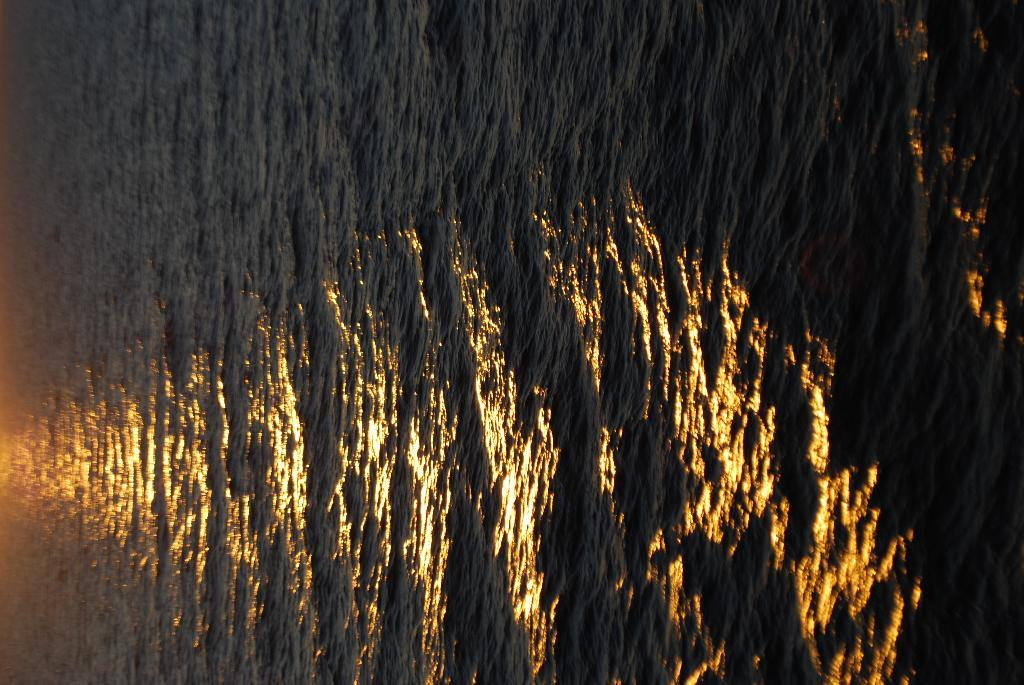Where was the image taken? The image is taken outdoors. What type of natural feature can be seen in the image? There is a sea in the image. What type of basin is visible in the image? There is no basin present in the image. What is the rate of the waves in the sea in the image? The image does not provide information about the rate of the waves in the sea. What type of silver object can be seen in the image? There is no silver object present in the image. 